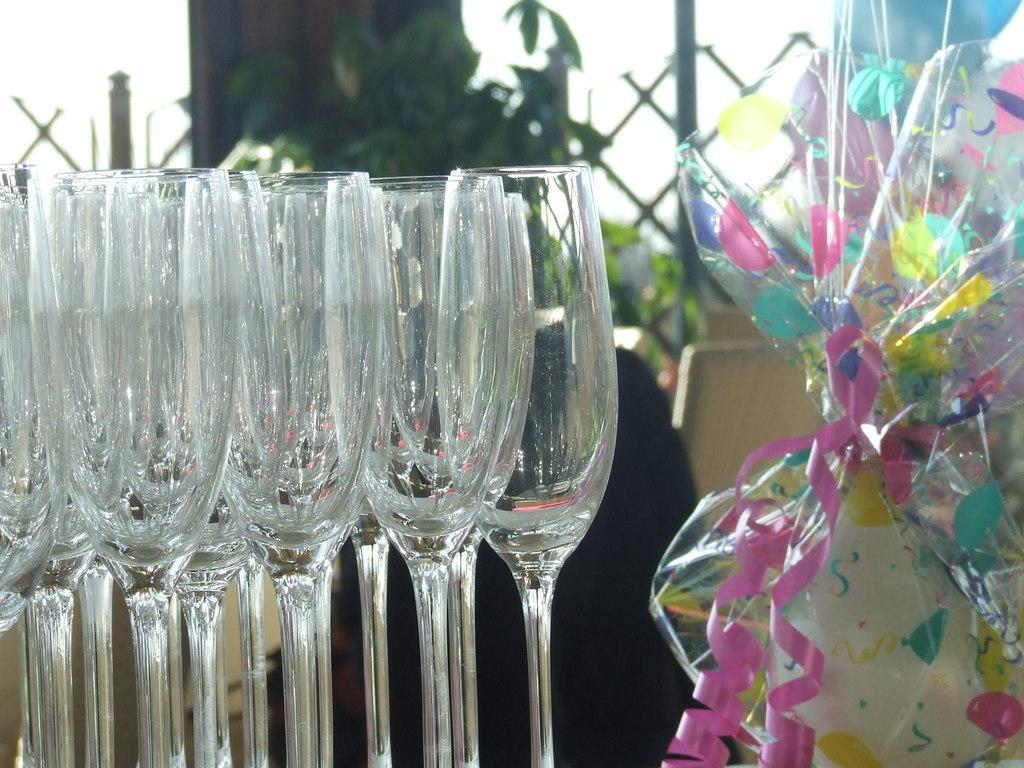What objects can be seen in the image? There are glasses, a gift wrapped in a cover, and a plant in the background of the image. What else is visible in the background of the image? There is a grill and chairs in the background of the image. What type of anger is being expressed by the gift in the image? There is no anger expressed by the gift in the image, as it is a wrapped gift and not a living being capable of expressing emotions. 